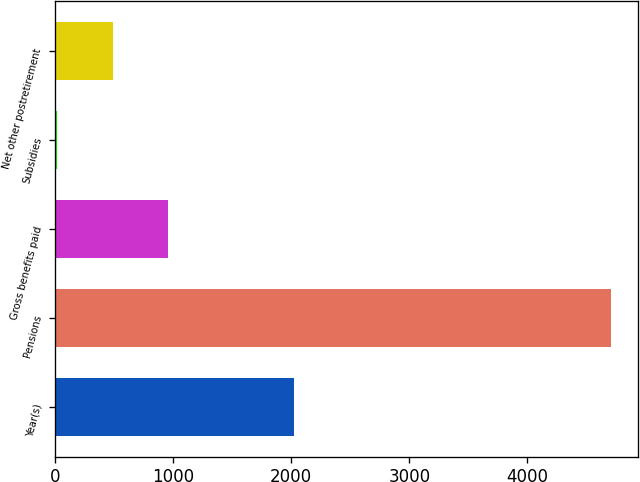Convert chart. <chart><loc_0><loc_0><loc_500><loc_500><bar_chart><fcel>Year(s)<fcel>Pensions<fcel>Gross benefits paid<fcel>Subsidies<fcel>Net other postretirement<nl><fcel>2020<fcel>4706<fcel>954.8<fcel>17<fcel>485.9<nl></chart> 